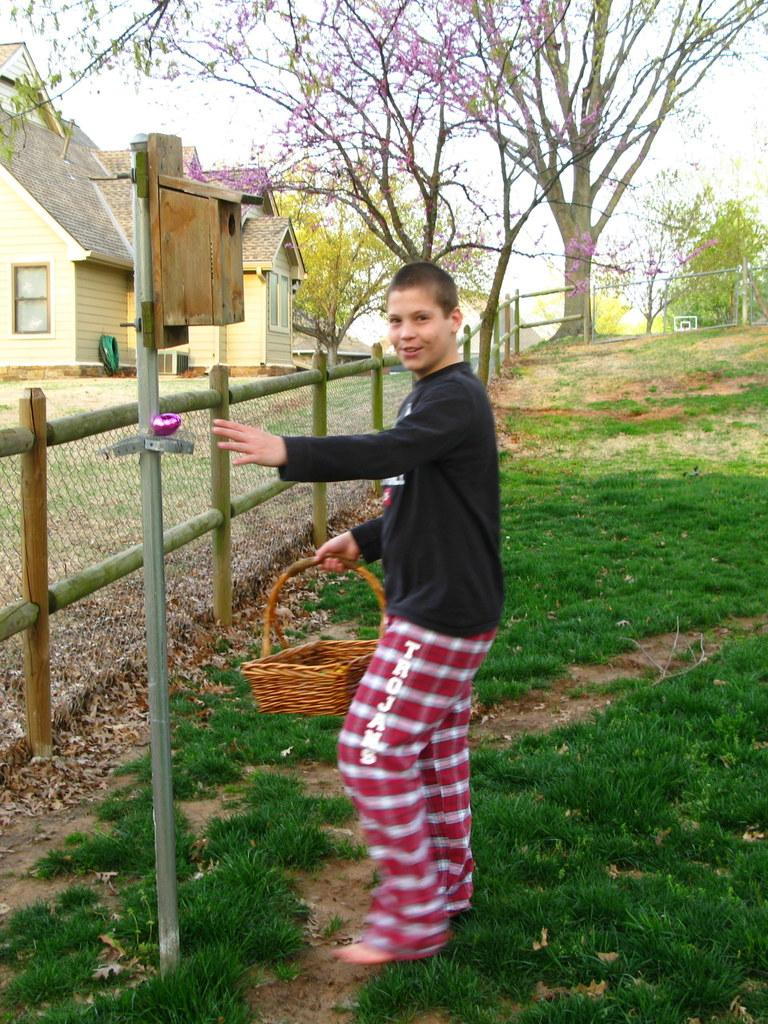What is the main subject of the image? The main subject of the image is a boy standing in the middle. What is the boy holding in the image? The boy is holding a basket. What type of terrain is visible behind the boy? There is grass behind the boy. What structures are visible behind the boy? There is a pole, fencing, trees, and buildings behind the boy. What type of cats can be seen interacting with the flesh in the image? There are no cats or flesh present in the image. What effect does the boy's presence have on the environment in the image? The provided facts do not mention any effect the boy's presence has on the environment in the image. 